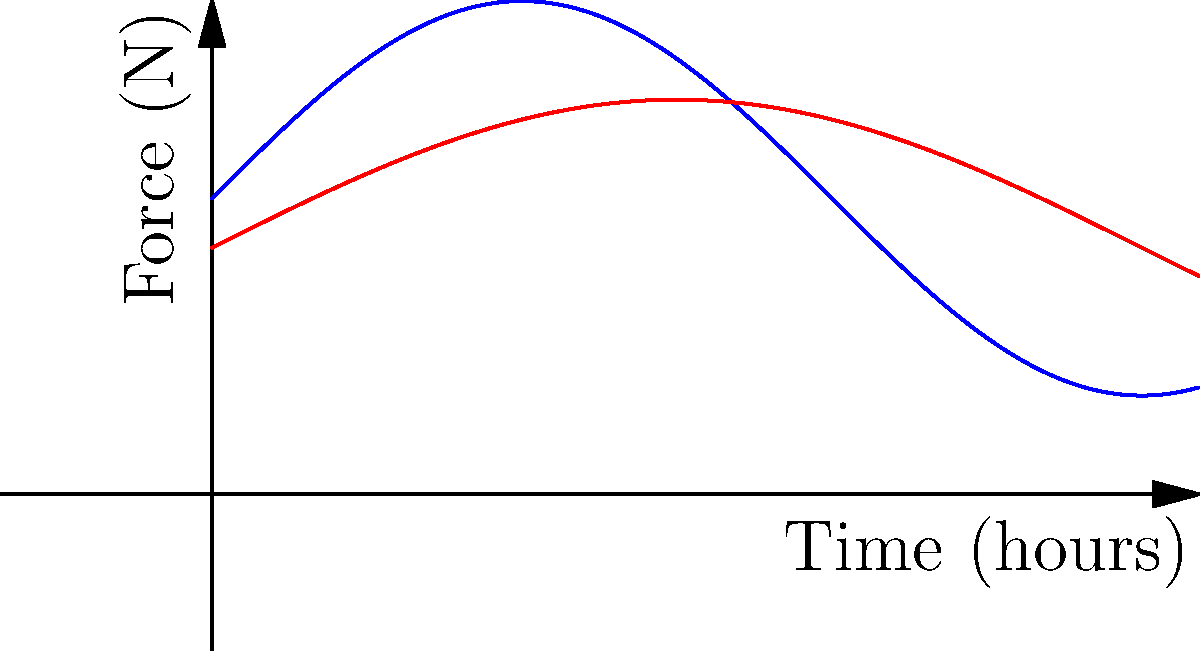Based on the graph showing the force exerted on the wrist and fingers over time for chess piece manipulation and mouse usage, which activity generally requires more force throughout the day? How does this relate to potential repetitive strain injuries (RSI) in tech and chess environments? To answer this question, we need to analyze the graph and understand the implications:

1. Observe the two curves:
   - Blue curve represents chess piece manipulation
   - Red curve represents mouse usage

2. Compare the average force levels:
   - The chess curve oscillates between approximately 1 N and 5 N
   - The mouse curve oscillates between approximately 1 N and 4 N

3. Calculate the average force:
   - Chess: $\frac{1 + 5}{2} = 3$ N (approximate average)
   - Mouse: $\frac{1 + 4}{2} = 2.5$ N (approximate average)

4. Interpret the results:
   - Chess piece manipulation generally requires more force throughout the day

5. Relate to RSI:
   - Higher force requirements in chess may lead to increased risk of RSI in fingers and wrist
   - Prolonged mouse usage, despite lower force, can still contribute to RSI due to its continuous nature in tech work

6. Consider the implications:
   - Tech entrepreneurs who were former chess players might be at higher risk for RSI
   - Awareness of proper ergonomics and regular breaks are crucial in both activities
Answer: Chess piece manipulation; higher risk of RSI in both activities 